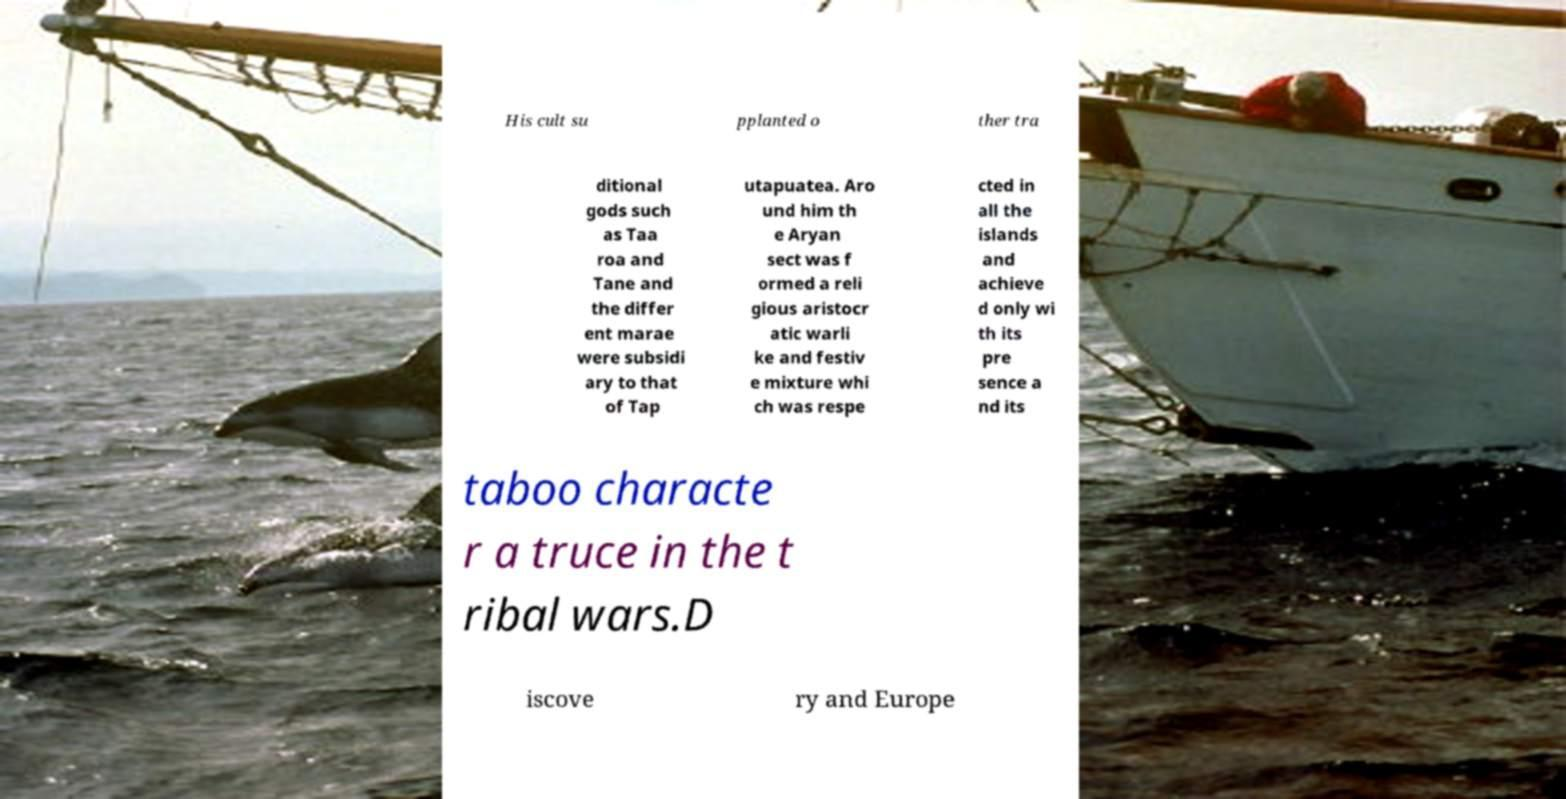Could you extract and type out the text from this image? His cult su pplanted o ther tra ditional gods such as Taa roa and Tane and the differ ent marae were subsidi ary to that of Tap utapuatea. Aro und him th e Aryan sect was f ormed a reli gious aristocr atic warli ke and festiv e mixture whi ch was respe cted in all the islands and achieve d only wi th its pre sence a nd its taboo characte r a truce in the t ribal wars.D iscove ry and Europe 